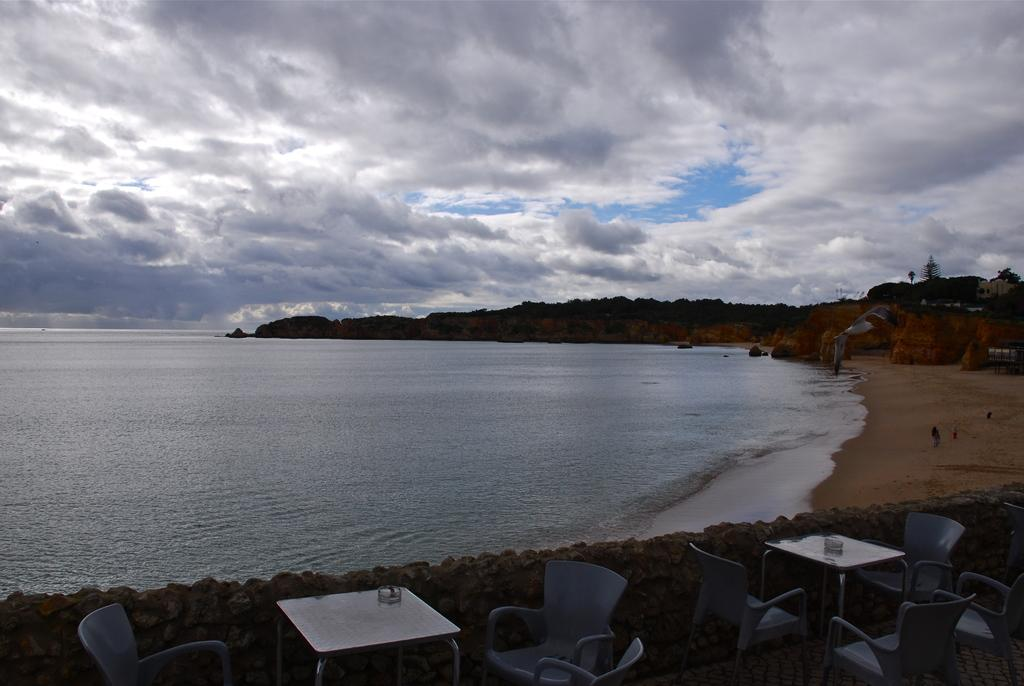What type of furniture is present in the image? There are chairs and tables in the image. What other objects can be seen in the image? There are stones, trees, water, and rocks visible in the image. What is the color of the sky in the image? The sky is blue and white in color. What type of debt is being discussed in the image? There is no mention of debt in the image; it features chairs, tables, stones, trees, water, rocks, and a blue and white sky. How does the acoustics of the area affect the conversation in the image? There is no conversation taking place in the image, so it is impossible to determine how the acoustics might affect it. 